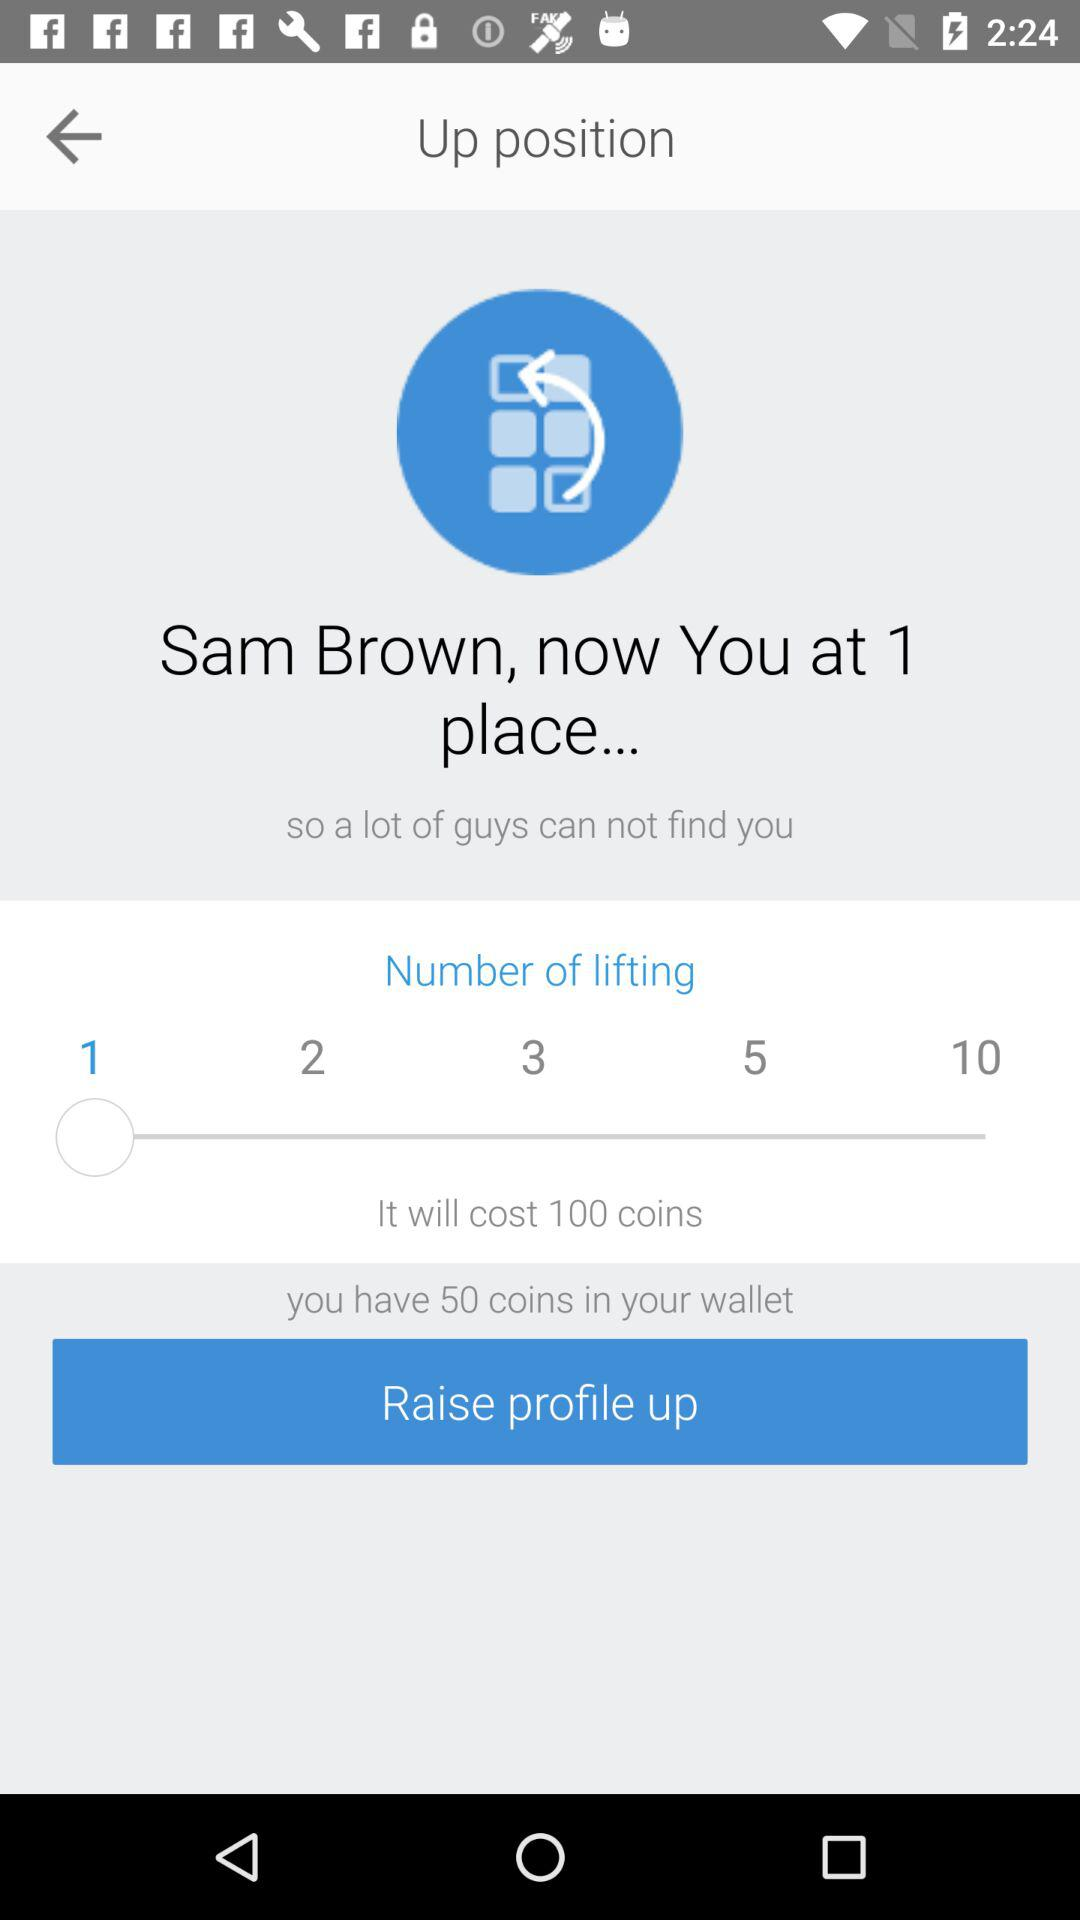When will Sam be at the second place?
When the provided information is insufficient, respond with <no answer>. <no answer> 